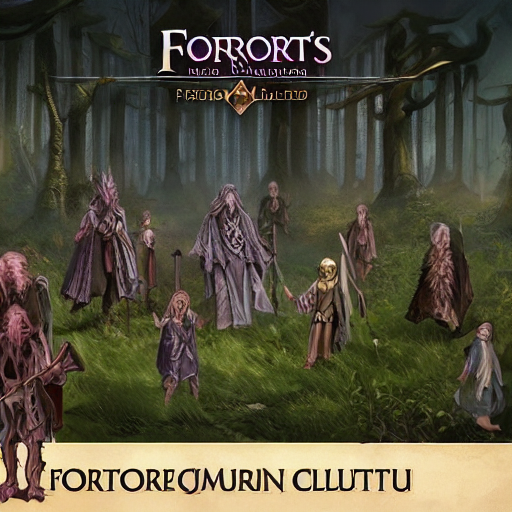Can you describe the atmosphere or setting conveyed in this artwork? The artwork presents a mystical and eerie forest scene. Shrouded in mist, the setting evokes a sense of mystery and ancient magic. The cloaked figures, with their varied stances and mysterious garb, contribute to a narrative that suggests a gathering of beings with potentially supernatural attributes. There is an overarching theme of fantasy, potentially hinting at a moment before a significant event or ritual in the story depicted. 